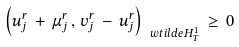Convert formula to latex. <formula><loc_0><loc_0><loc_500><loc_500>\left ( u ^ { r } _ { j } \, + \, \mu ^ { r } _ { j } \, , \, v ^ { r } _ { j } \, - \, u ^ { r } _ { j } \right ) _ { \ w t i l d e { H } ^ { 1 } _ { T } } \, \geq \, 0</formula> 